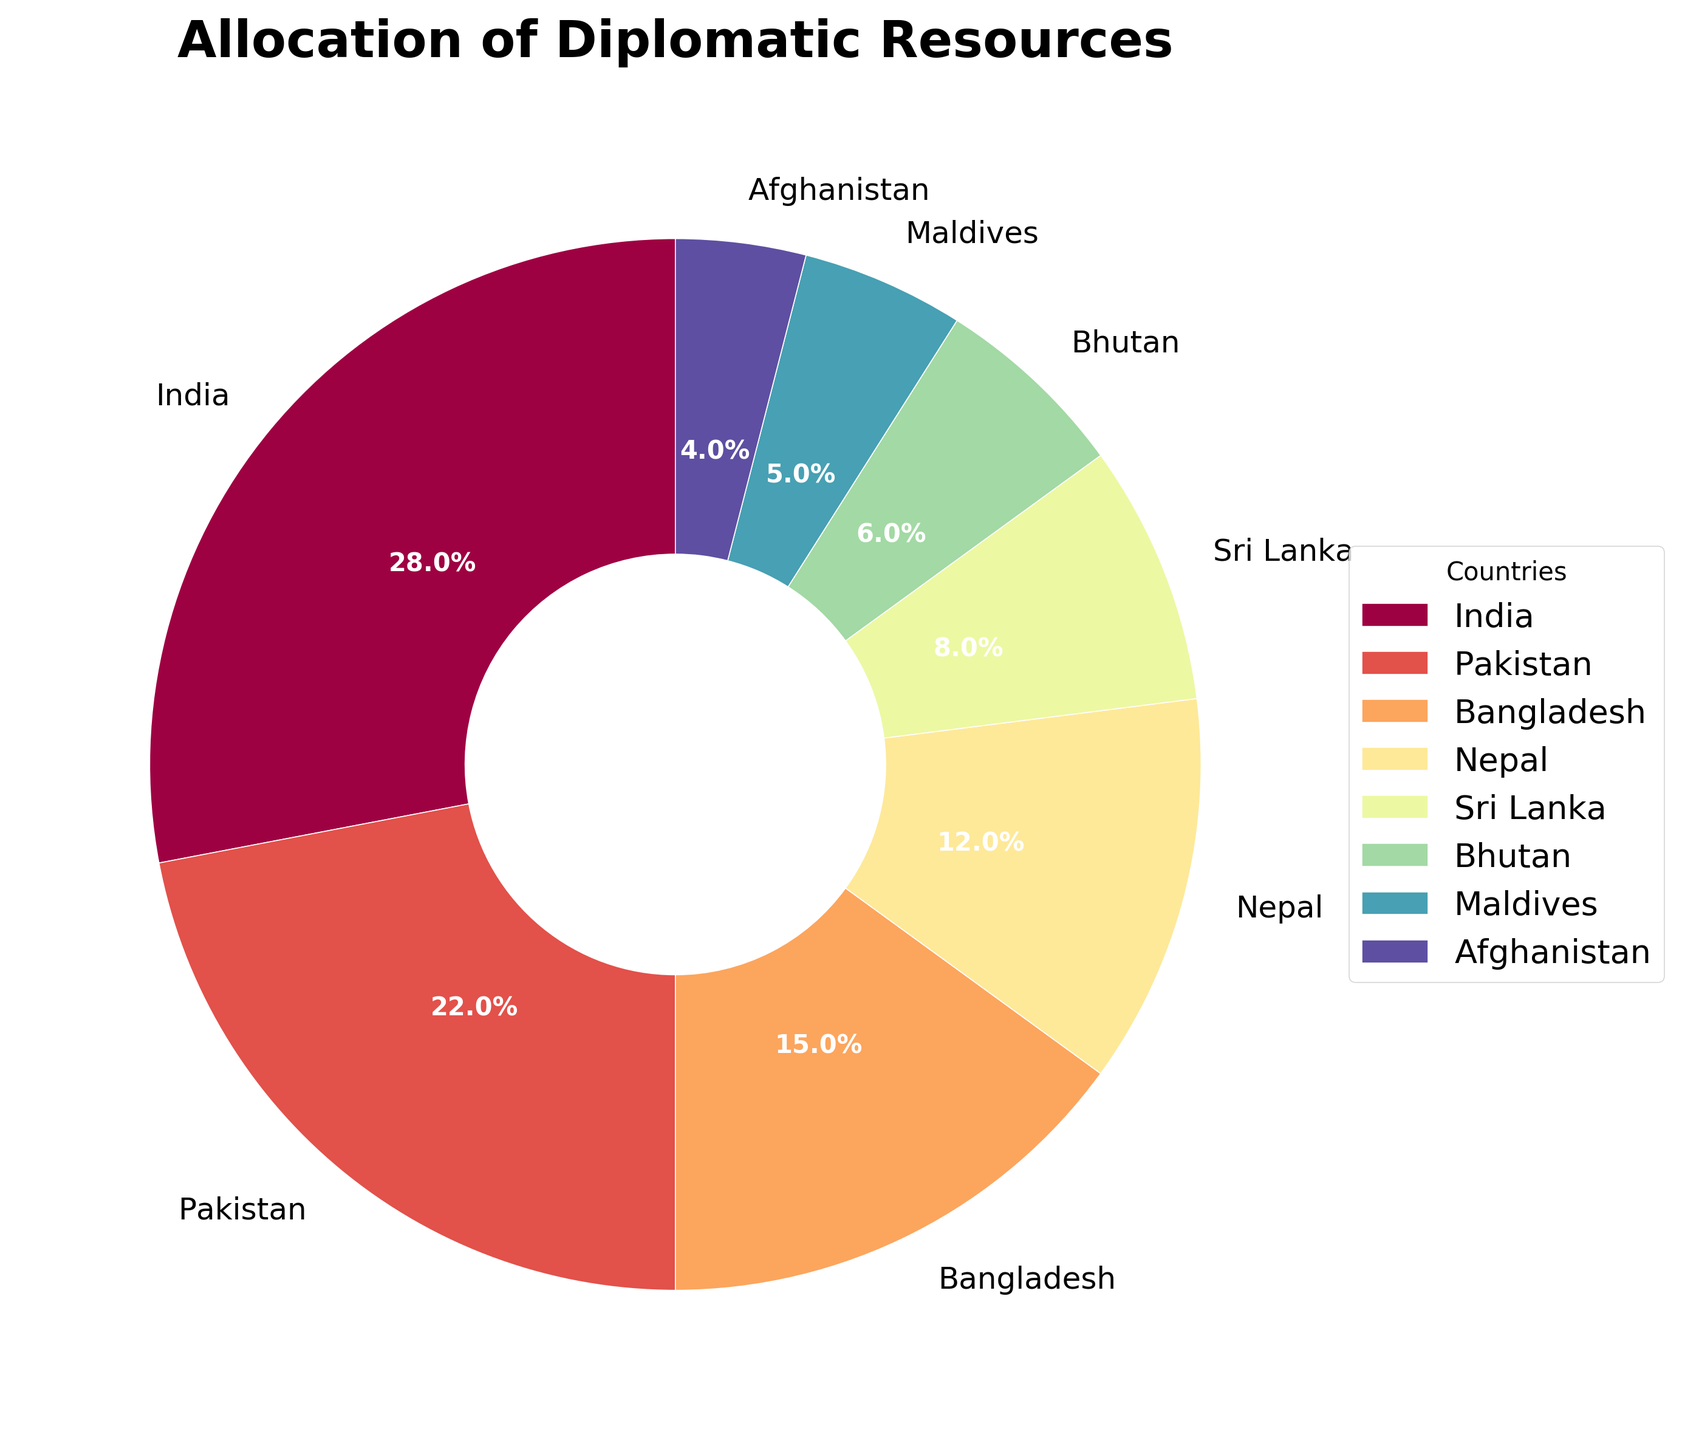Which country has the highest allocation of diplomatic resources? By looking at the pie chart, you can compare the segments by size. The largest segment corresponds to India.
Answer: India Which countries together account for 50% or more of the diplomatic resources? First, identify the allocations for each country: India (28%) and Pakistan (22%). Adding them together (28% + 22%), we reach 50%.
Answer: India and Pakistan How does the resource allocation to Nepal compare to that of Bangladesh? From the pie chart, the allocation to Bangladesh is 15%, whereas Nepal's allocation is 12%. Bangladesh has a higher percentage.
Answer: Bangladesh has a higher percentage than Nepal What's the combined allocation of diplomatic resources for Sri Lanka and Bhutan? Sri Lanka's allocation is 8%, and Bhutan's is 6%. Adding these together (8% + 6%), we get 14%.
Answer: 14% Which segment represents the smallest allocation, and what is the value? By visually inspecting the smallest segment of the pie chart, it corresponds to Afghanistan, with an allocation of 4%.
Answer: Afghanistan, 4% What is the difference in resource allocation between Pakistan and Maldives? Pakistan's allocation is 22%, and Maldives' is 5%. Subtracting these (22% - 5%), we get a difference of 17%.
Answer: 17% Which countries have allocations less than 10%? Visually identifying the countries with smaller segments, we find Sri Lanka (8%), Bhutan (6%), Maldives (5%), and Afghanistan (4%).
Answer: Sri Lanka, Bhutan, Maldives, Afghanistan What fraction of the pie chart does the resource allocation for Nepal represent? The allocation for Nepal is 12%. Since the entire pie chart represents 100%, the fraction is 12/100 or 0.12.
Answer: 0.12 How much greater is India's allocation compared to Afghanistan's? India's allocation is 28%, and Afghanistan's is 4%. Subtracting these (28% - 4%), we find that India’s allocation is 24% greater.
Answer: 24% 